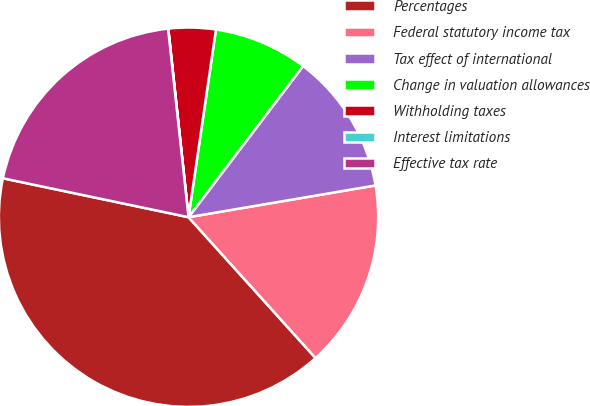Convert chart. <chart><loc_0><loc_0><loc_500><loc_500><pie_chart><fcel>Percentages<fcel>Federal statutory income tax<fcel>Tax effect of international<fcel>Change in valuation allowances<fcel>Withholding taxes<fcel>Interest limitations<fcel>Effective tax rate<nl><fcel>39.97%<fcel>16.0%<fcel>12.0%<fcel>8.01%<fcel>4.01%<fcel>0.02%<fcel>19.99%<nl></chart> 